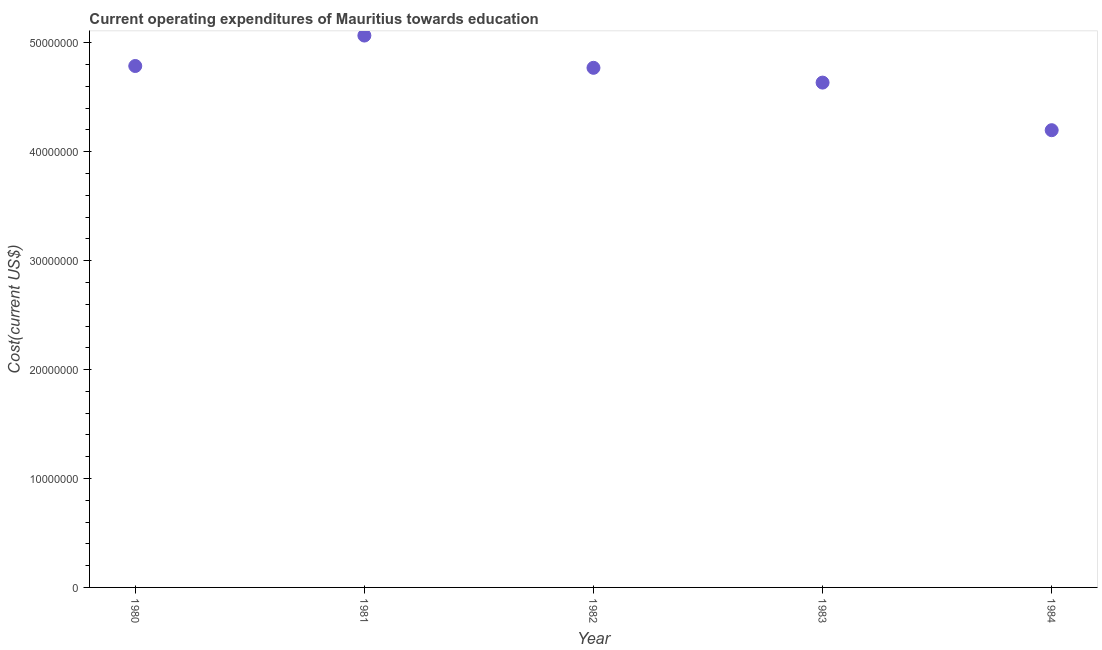What is the education expenditure in 1983?
Offer a very short reply. 4.64e+07. Across all years, what is the maximum education expenditure?
Make the answer very short. 5.07e+07. Across all years, what is the minimum education expenditure?
Give a very brief answer. 4.20e+07. In which year was the education expenditure minimum?
Make the answer very short. 1984. What is the sum of the education expenditure?
Offer a very short reply. 2.35e+08. What is the difference between the education expenditure in 1982 and 1983?
Your answer should be compact. 1.36e+06. What is the average education expenditure per year?
Your response must be concise. 4.69e+07. What is the median education expenditure?
Offer a terse response. 4.77e+07. What is the ratio of the education expenditure in 1983 to that in 1984?
Your answer should be compact. 1.1. Is the education expenditure in 1981 less than that in 1982?
Your answer should be very brief. No. Is the difference between the education expenditure in 1981 and 1983 greater than the difference between any two years?
Your answer should be very brief. No. What is the difference between the highest and the second highest education expenditure?
Make the answer very short. 2.80e+06. What is the difference between the highest and the lowest education expenditure?
Your response must be concise. 8.69e+06. In how many years, is the education expenditure greater than the average education expenditure taken over all years?
Provide a short and direct response. 3. Does the education expenditure monotonically increase over the years?
Ensure brevity in your answer.  No. Are the values on the major ticks of Y-axis written in scientific E-notation?
Make the answer very short. No. Does the graph contain any zero values?
Offer a very short reply. No. Does the graph contain grids?
Your response must be concise. No. What is the title of the graph?
Offer a very short reply. Current operating expenditures of Mauritius towards education. What is the label or title of the X-axis?
Offer a very short reply. Year. What is the label or title of the Y-axis?
Your answer should be very brief. Cost(current US$). What is the Cost(current US$) in 1980?
Offer a terse response. 4.79e+07. What is the Cost(current US$) in 1981?
Your response must be concise. 5.07e+07. What is the Cost(current US$) in 1982?
Offer a very short reply. 4.77e+07. What is the Cost(current US$) in 1983?
Make the answer very short. 4.64e+07. What is the Cost(current US$) in 1984?
Your answer should be very brief. 4.20e+07. What is the difference between the Cost(current US$) in 1980 and 1981?
Offer a very short reply. -2.80e+06. What is the difference between the Cost(current US$) in 1980 and 1982?
Your response must be concise. 1.67e+05. What is the difference between the Cost(current US$) in 1980 and 1983?
Your answer should be very brief. 1.52e+06. What is the difference between the Cost(current US$) in 1980 and 1984?
Give a very brief answer. 5.89e+06. What is the difference between the Cost(current US$) in 1981 and 1982?
Offer a very short reply. 2.96e+06. What is the difference between the Cost(current US$) in 1981 and 1983?
Your answer should be very brief. 4.32e+06. What is the difference between the Cost(current US$) in 1981 and 1984?
Keep it short and to the point. 8.69e+06. What is the difference between the Cost(current US$) in 1982 and 1983?
Keep it short and to the point. 1.36e+06. What is the difference between the Cost(current US$) in 1982 and 1984?
Offer a very short reply. 5.73e+06. What is the difference between the Cost(current US$) in 1983 and 1984?
Ensure brevity in your answer.  4.37e+06. What is the ratio of the Cost(current US$) in 1980 to that in 1981?
Keep it short and to the point. 0.94. What is the ratio of the Cost(current US$) in 1980 to that in 1983?
Provide a short and direct response. 1.03. What is the ratio of the Cost(current US$) in 1980 to that in 1984?
Your answer should be compact. 1.14. What is the ratio of the Cost(current US$) in 1981 to that in 1982?
Your answer should be compact. 1.06. What is the ratio of the Cost(current US$) in 1981 to that in 1983?
Your answer should be very brief. 1.09. What is the ratio of the Cost(current US$) in 1981 to that in 1984?
Offer a terse response. 1.21. What is the ratio of the Cost(current US$) in 1982 to that in 1983?
Provide a succinct answer. 1.03. What is the ratio of the Cost(current US$) in 1982 to that in 1984?
Offer a very short reply. 1.14. What is the ratio of the Cost(current US$) in 1983 to that in 1984?
Ensure brevity in your answer.  1.1. 